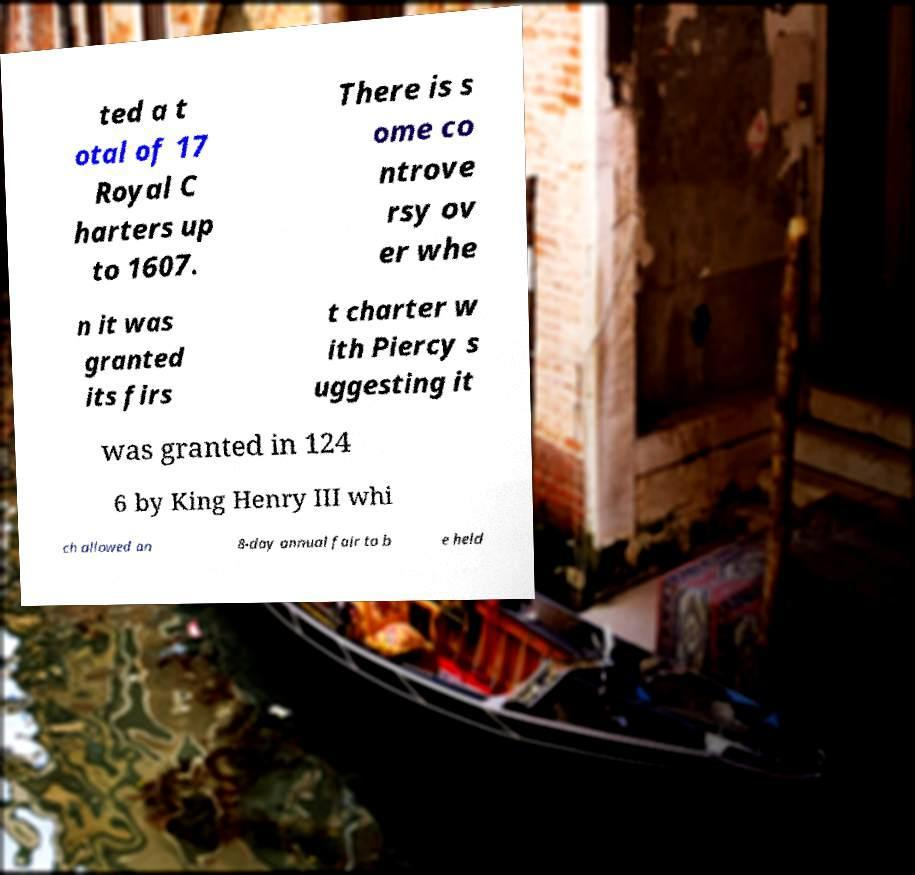Please identify and transcribe the text found in this image. ted a t otal of 17 Royal C harters up to 1607. There is s ome co ntrove rsy ov er whe n it was granted its firs t charter w ith Piercy s uggesting it was granted in 124 6 by King Henry III whi ch allowed an 8-day annual fair to b e held 